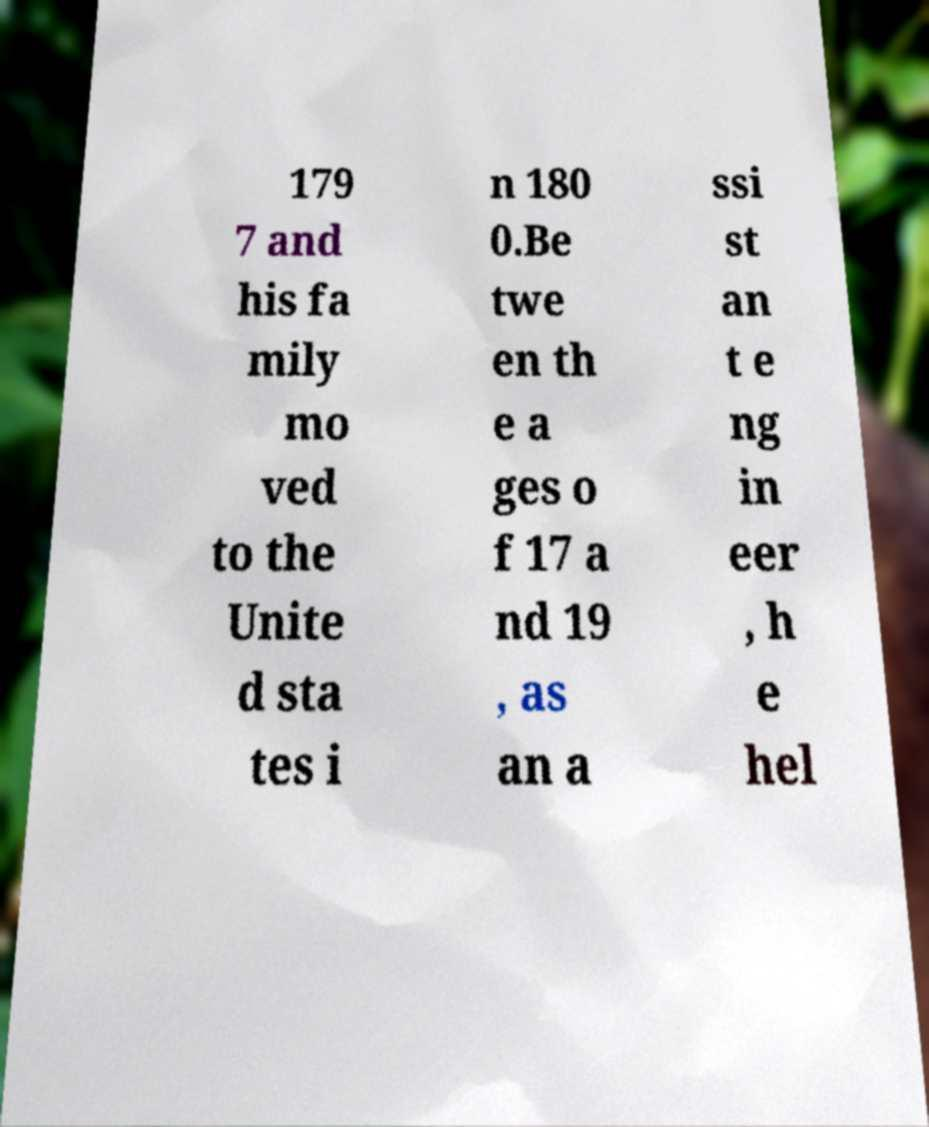Can you accurately transcribe the text from the provided image for me? 179 7 and his fa mily mo ved to the Unite d sta tes i n 180 0.Be twe en th e a ges o f 17 a nd 19 , as an a ssi st an t e ng in eer , h e hel 